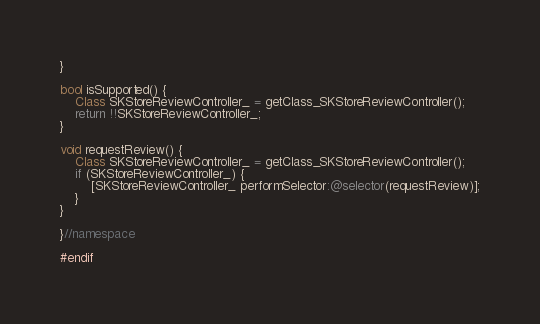<code> <loc_0><loc_0><loc_500><loc_500><_ObjectiveC_>}

bool isSupported() {
    Class SKStoreReviewController_ = getClass_SKStoreReviewController();
    return !!SKStoreReviewController_;
}

void requestReview() {
    Class SKStoreReviewController_ = getClass_SKStoreReviewController();
    if (SKStoreReviewController_) {
        [SKStoreReviewController_ performSelector:@selector(requestReview)];
    }
}

}//namespace

#endif
</code> 